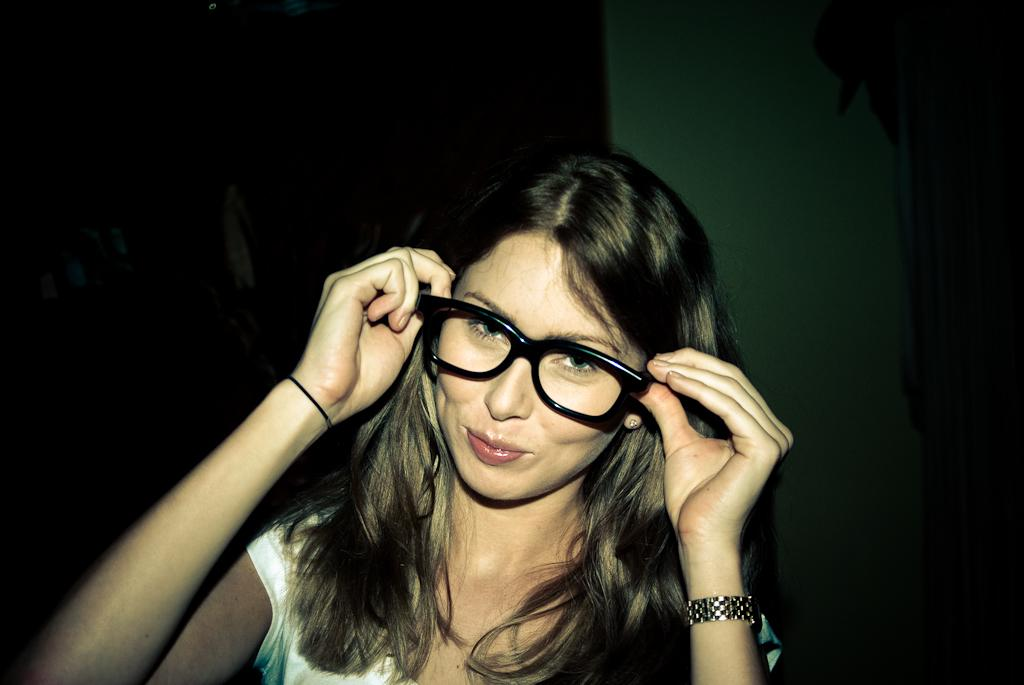Who is the main subject in the image? There is a lady in the image. What is the lady holding in the image? The lady is holding speeds. What can be seen behind the lady in the image? There is a wall behind the lady. How would you describe the overall lighting in the image? The background of the image is dark. What type of butter is being used in the scene depicted in the image? There is no butter present in the image, and no scene involving butter can be observed. 